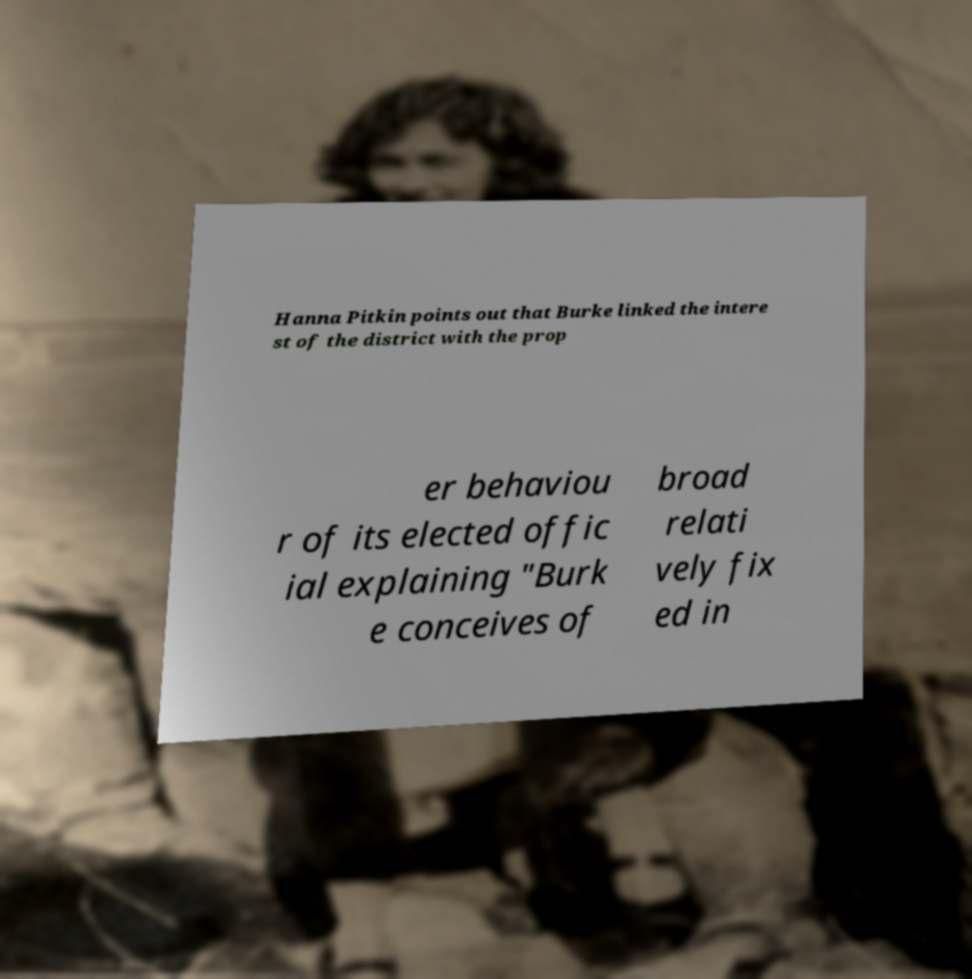There's text embedded in this image that I need extracted. Can you transcribe it verbatim? Hanna Pitkin points out that Burke linked the intere st of the district with the prop er behaviou r of its elected offic ial explaining "Burk e conceives of broad relati vely fix ed in 